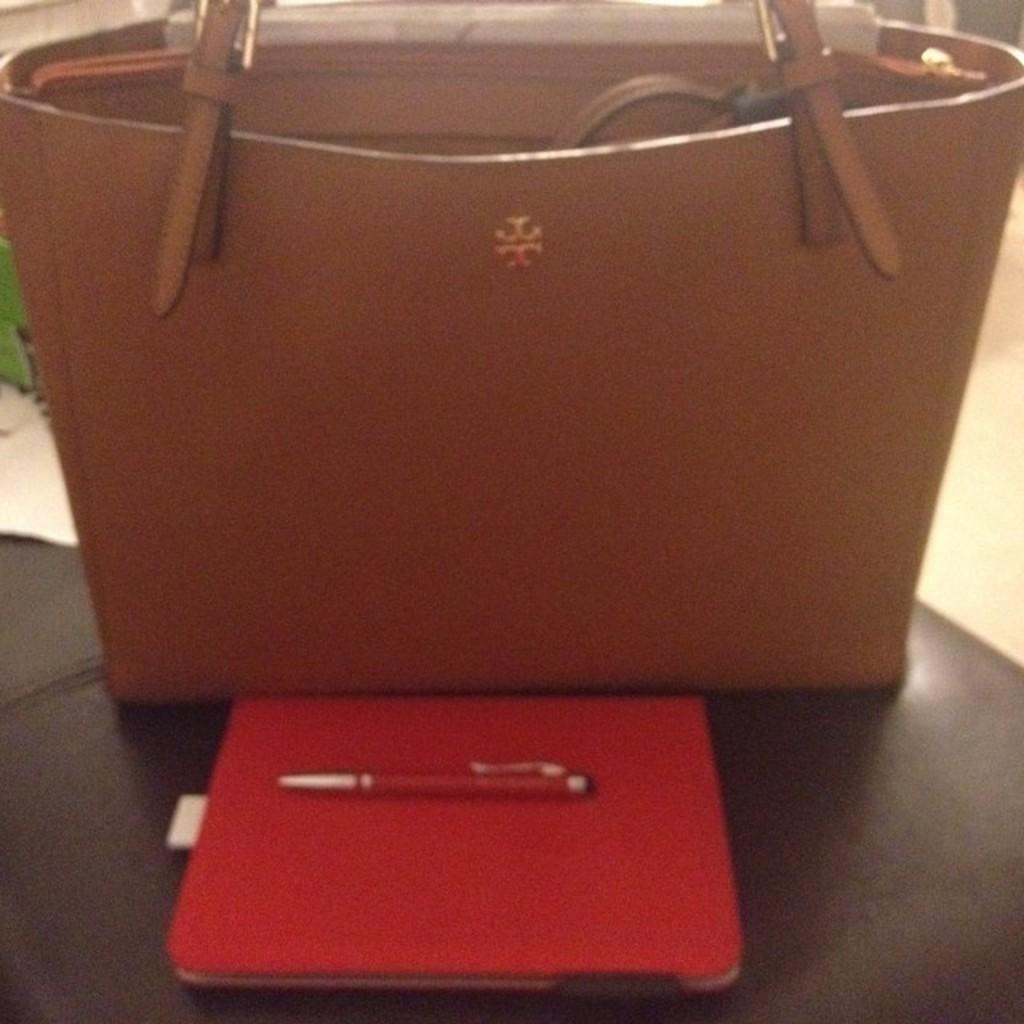How would you summarize this image in a sentence or two? This is a picture of a hand bag which is brown in color and there is a book and pen in front of the bag. 